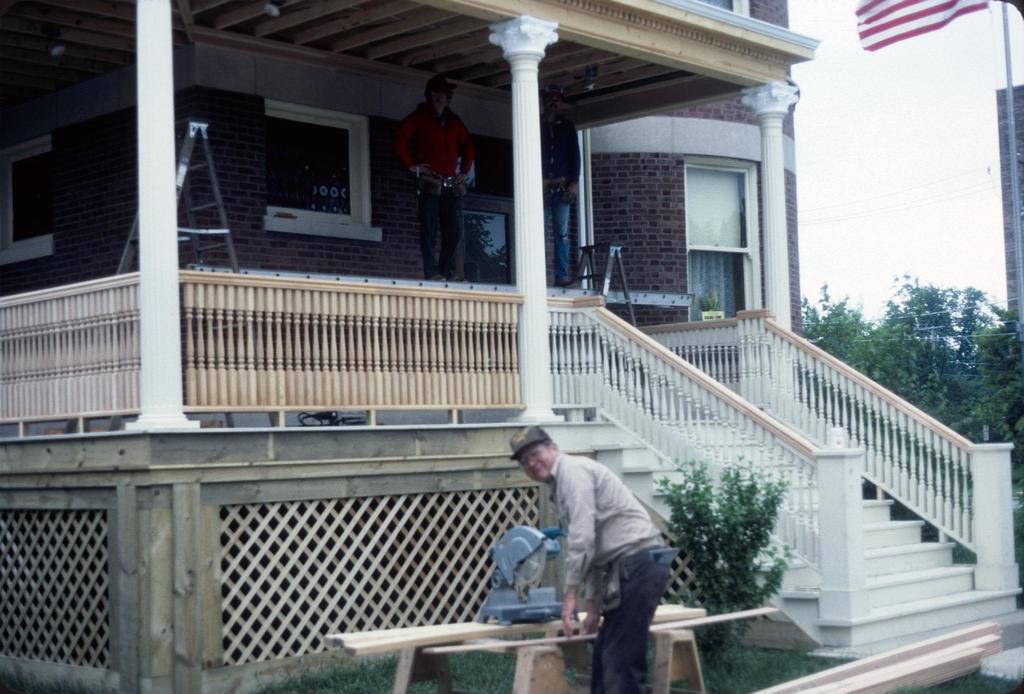Could you give a brief overview of what you see in this image? The man in front of the picture is standing and he is smiling. In front of him,we see the wooden bench on which a wood cutter is placed. I think he is cutting the wood. Beside him, we see a plant. At the bottom, we see grass and wood. Behind him, we see the staircase and the stair railing. In the background, we see two men are standing on the stand. Beside that, we see a ladder. Behind them, we see a wall which is made up of bricks. We even see the windows. On the right side, we see trees and a flagpole. We see a flag in white and red color. 